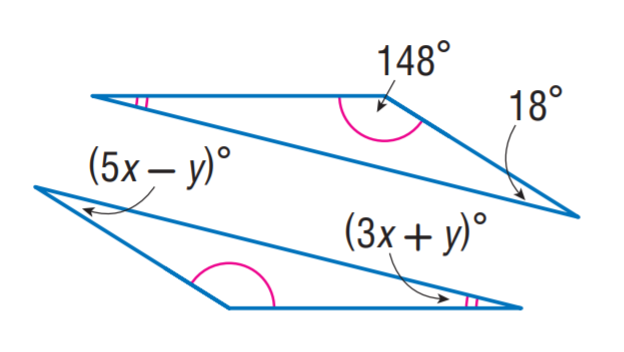Answer the mathemtical geometry problem and directly provide the correct option letter.
Question: Find x.
Choices: A: 2 B: 3 C: 4 D: 5 C 